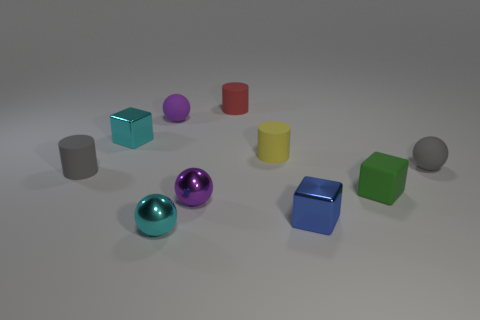What is the shape of the small yellow rubber thing in front of the tiny purple thing that is behind the yellow thing?
Provide a short and direct response. Cylinder. There is a small purple shiny object; is it the same shape as the gray thing that is to the right of the red object?
Offer a terse response. Yes. There is another metal cube that is the same size as the blue shiny block; what is its color?
Offer a very short reply. Cyan. Is the number of small rubber blocks in front of the matte block less than the number of purple spheres that are to the left of the small purple metal ball?
Your answer should be compact. Yes. What is the shape of the tiny purple metal object on the left side of the cylinder that is behind the purple thing behind the small yellow cylinder?
Make the answer very short. Sphere. Does the tiny cylinder in front of the small gray rubber ball have the same color as the rubber ball on the right side of the green object?
Provide a short and direct response. Yes. What number of metallic things are green things or large blue cubes?
Offer a terse response. 0. There is a metal cube that is in front of the tiny cylinder on the left side of the shiny cube that is on the left side of the small blue metallic thing; what is its color?
Your answer should be very brief. Blue. What color is the small rubber thing that is the same shape as the tiny blue metallic thing?
Offer a terse response. Green. How many other things are made of the same material as the small red cylinder?
Provide a short and direct response. 5. 